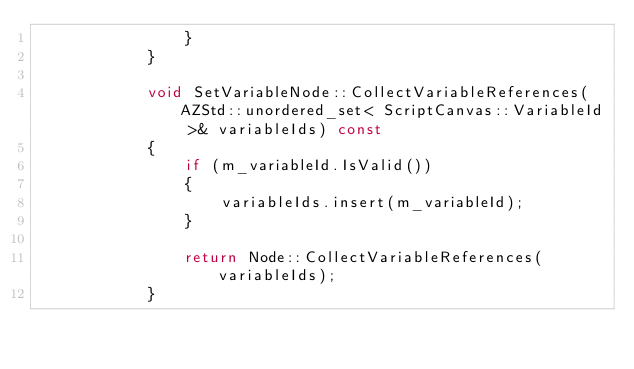<code> <loc_0><loc_0><loc_500><loc_500><_C++_>                }
            }

            void SetVariableNode::CollectVariableReferences(AZStd::unordered_set< ScriptCanvas::VariableId >& variableIds) const
            {
                if (m_variableId.IsValid())
                {
                    variableIds.insert(m_variableId);
                }

                return Node::CollectVariableReferences(variableIds);
            }
</code> 